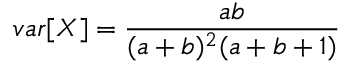<formula> <loc_0><loc_0><loc_500><loc_500>v a r [ X ] = \frac { a b } { ( a + b ) ^ { 2 } ( a + b + 1 ) }</formula> 